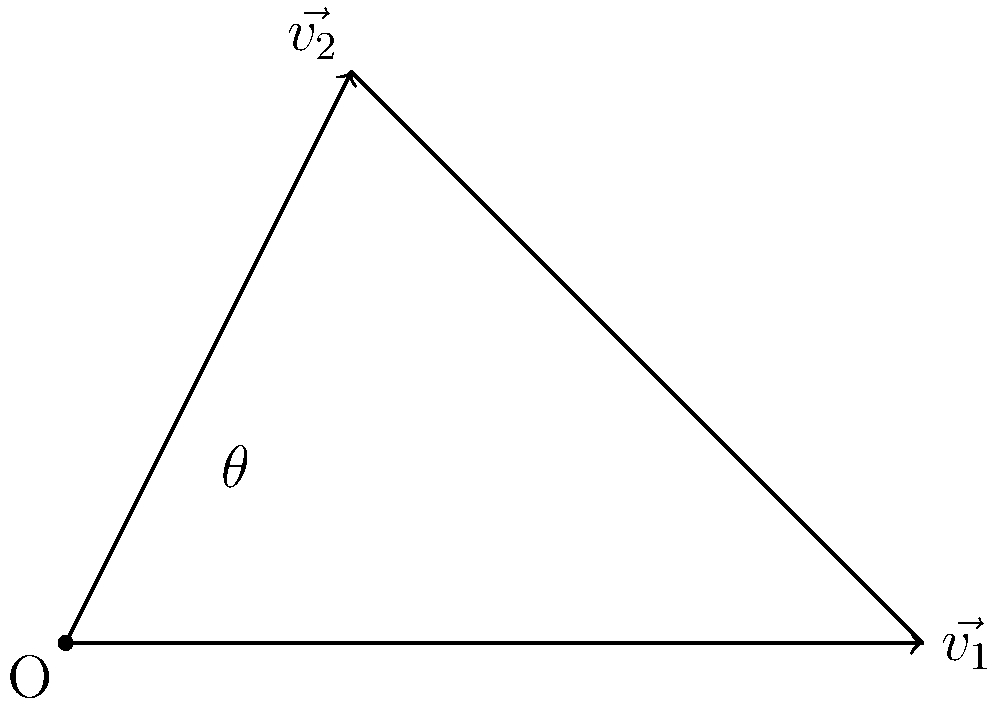In a collision between two vehicles, their velocity vectors immediately before impact are represented as $\vec{v_1}$ and $\vec{v_2}$ in the diagram. $\vec{v_1}$ has a magnitude of 3 units and is parallel to the x-axis, while $\vec{v_2}$ has components (1, 2). What is the angle of impact $\theta$ between these two vectors? Let's approach this step-by-step:

1) First, we need to recall the formula for the angle between two vectors:

   $$\cos \theta = \frac{\vec{v_1} \cdot \vec{v_2}}{|\vec{v_1}||\vec{v_2}|}$$

2) We know $\vec{v_1} = (3, 0)$ and $\vec{v_2} = (1, 2)$

3) Let's calculate the dot product $\vec{v_1} \cdot \vec{v_2}$:
   
   $\vec{v_1} \cdot \vec{v_2} = (3)(1) + (0)(2) = 3$

4) Now, let's calculate the magnitudes:
   
   $|\vec{v_1}| = \sqrt{3^2 + 0^2} = 3$
   
   $|\vec{v_2}| = \sqrt{1^2 + 2^2} = \sqrt{5}$

5) Substituting into our formula:

   $$\cos \theta = \frac{3}{3\sqrt{5}} = \frac{1}{\sqrt{5}}$$

6) To find $\theta$, we need to take the inverse cosine (arccos) of both sides:

   $$\theta = \arccos(\frac{1}{\sqrt{5}})$$

7) Using a calculator or computer, we can evaluate this:

   $$\theta \approx 63.4^\circ$$

This angle represents the angle of impact between the two vehicles.
Answer: $63.4^\circ$ 